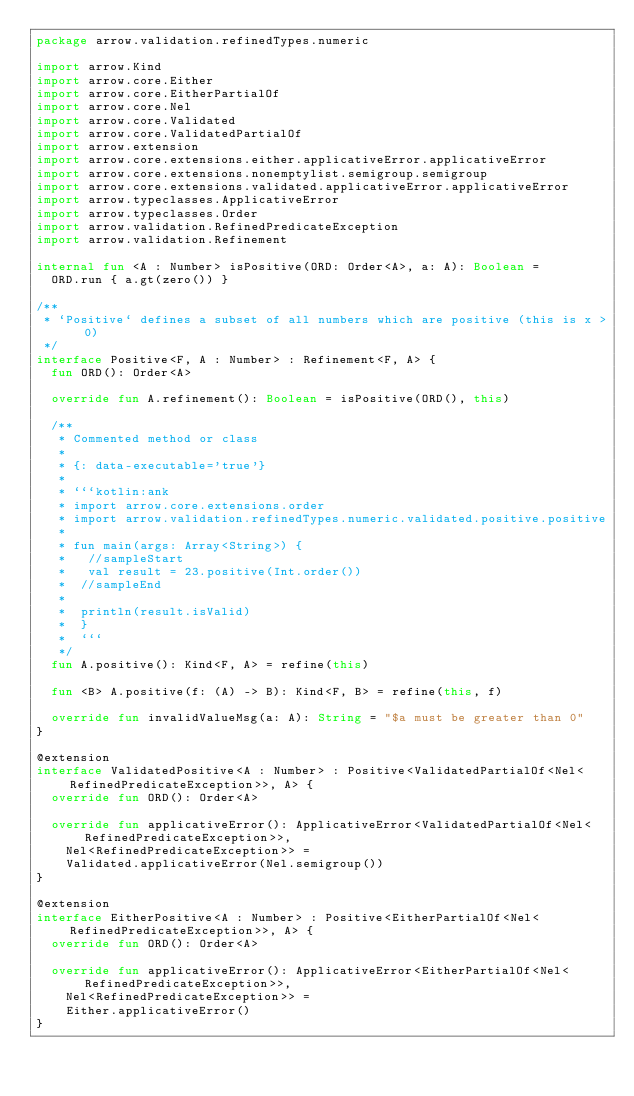Convert code to text. <code><loc_0><loc_0><loc_500><loc_500><_Kotlin_>package arrow.validation.refinedTypes.numeric

import arrow.Kind
import arrow.core.Either
import arrow.core.EitherPartialOf
import arrow.core.Nel
import arrow.core.Validated
import arrow.core.ValidatedPartialOf
import arrow.extension
import arrow.core.extensions.either.applicativeError.applicativeError
import arrow.core.extensions.nonemptylist.semigroup.semigroup
import arrow.core.extensions.validated.applicativeError.applicativeError
import arrow.typeclasses.ApplicativeError
import arrow.typeclasses.Order
import arrow.validation.RefinedPredicateException
import arrow.validation.Refinement

internal fun <A : Number> isPositive(ORD: Order<A>, a: A): Boolean =
  ORD.run { a.gt(zero()) }

/**
 * `Positive` defines a subset of all numbers which are positive (this is x > 0)
 */
interface Positive<F, A : Number> : Refinement<F, A> {
  fun ORD(): Order<A>

  override fun A.refinement(): Boolean = isPositive(ORD(), this)

  /**
   * Commented method or class
   *
   * {: data-executable='true'}
   *
   * ```kotlin:ank
   * import arrow.core.extensions.order
   * import arrow.validation.refinedTypes.numeric.validated.positive.positive
   *
   * fun main(args: Array<String>) {
   *   //sampleStart
   *   val result = 23.positive(Int.order())
   *  //sampleEnd
   *
   *  println(result.isValid)
   *  }
   *  ```
   */
  fun A.positive(): Kind<F, A> = refine(this)

  fun <B> A.positive(f: (A) -> B): Kind<F, B> = refine(this, f)

  override fun invalidValueMsg(a: A): String = "$a must be greater than 0"
}

@extension
interface ValidatedPositive<A : Number> : Positive<ValidatedPartialOf<Nel<RefinedPredicateException>>, A> {
  override fun ORD(): Order<A>

  override fun applicativeError(): ApplicativeError<ValidatedPartialOf<Nel<RefinedPredicateException>>,
    Nel<RefinedPredicateException>> =
    Validated.applicativeError(Nel.semigroup())
}

@extension
interface EitherPositive<A : Number> : Positive<EitherPartialOf<Nel<RefinedPredicateException>>, A> {
  override fun ORD(): Order<A>

  override fun applicativeError(): ApplicativeError<EitherPartialOf<Nel<RefinedPredicateException>>,
    Nel<RefinedPredicateException>> =
    Either.applicativeError()
}
</code> 